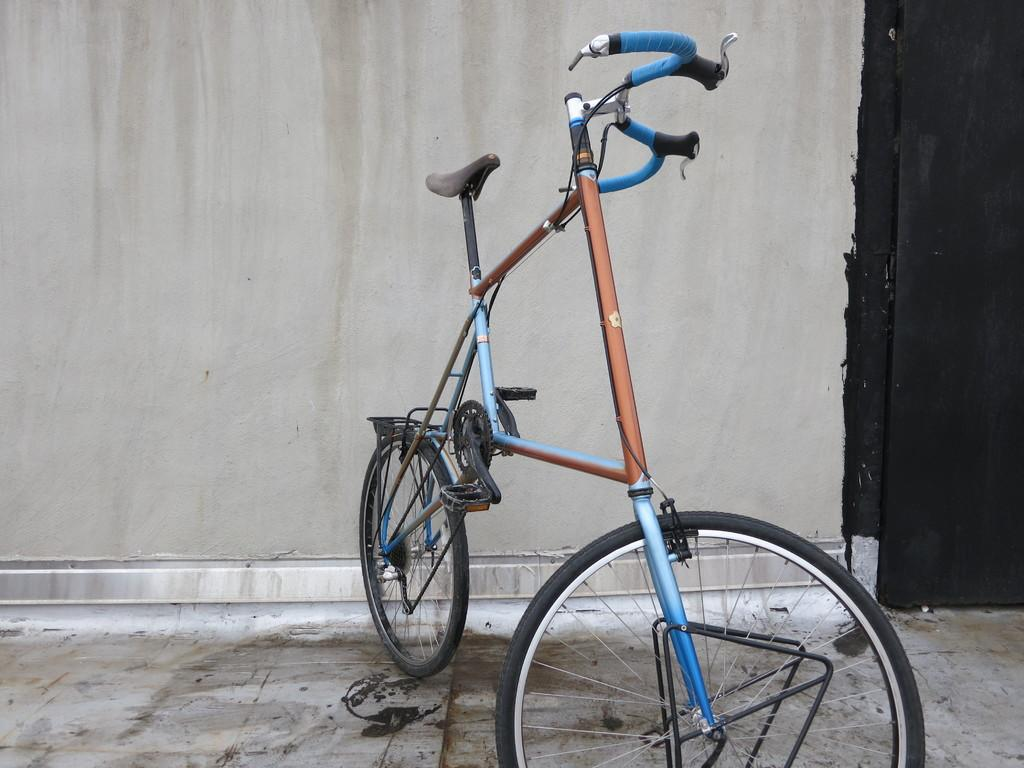What is the main object in the center of the image? There is a bicycle in the center of the image. What can be seen in the background of the image? There is a wall and a door in the background of the image. What part of the image shows the ground? The floor is visible at the bottom of the image. What type of plough is being used to grade the floor in the image? There is no plough or grading activity present in the image; it features a bicycle and background elements. 